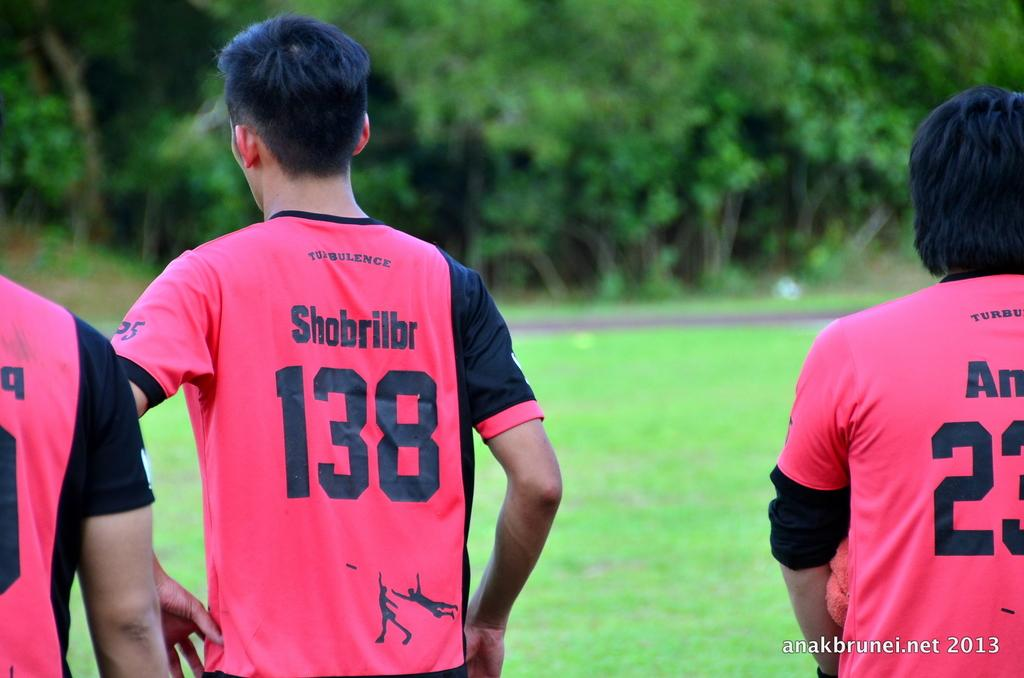<image>
Present a compact description of the photo's key features. The player with the name Shobrillbr has the number 138 on his jersey. 